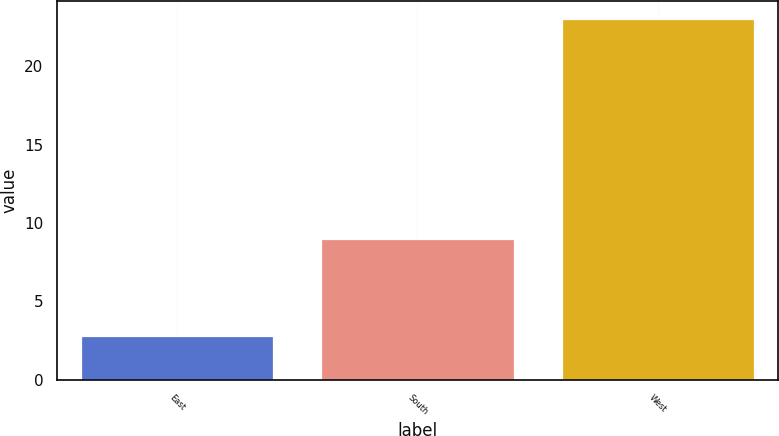Convert chart to OTSL. <chart><loc_0><loc_0><loc_500><loc_500><bar_chart><fcel>East<fcel>South<fcel>West<nl><fcel>2.81<fcel>9<fcel>23<nl></chart> 